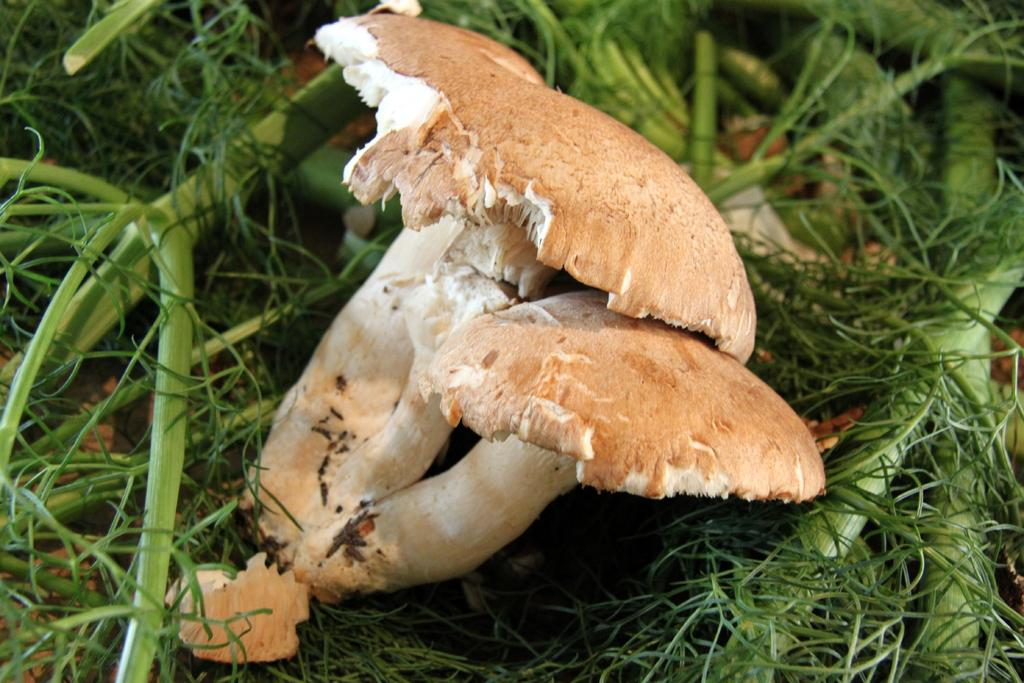What type of fungi can be seen in the image? There are mushrooms in the image. What can be seen in the background of the image? There are leaves in the background of the image. Is there a bridge made of liquid connecting the mushrooms in the image? No, there is no bridge made of liquid connecting the mushrooms in the image. 